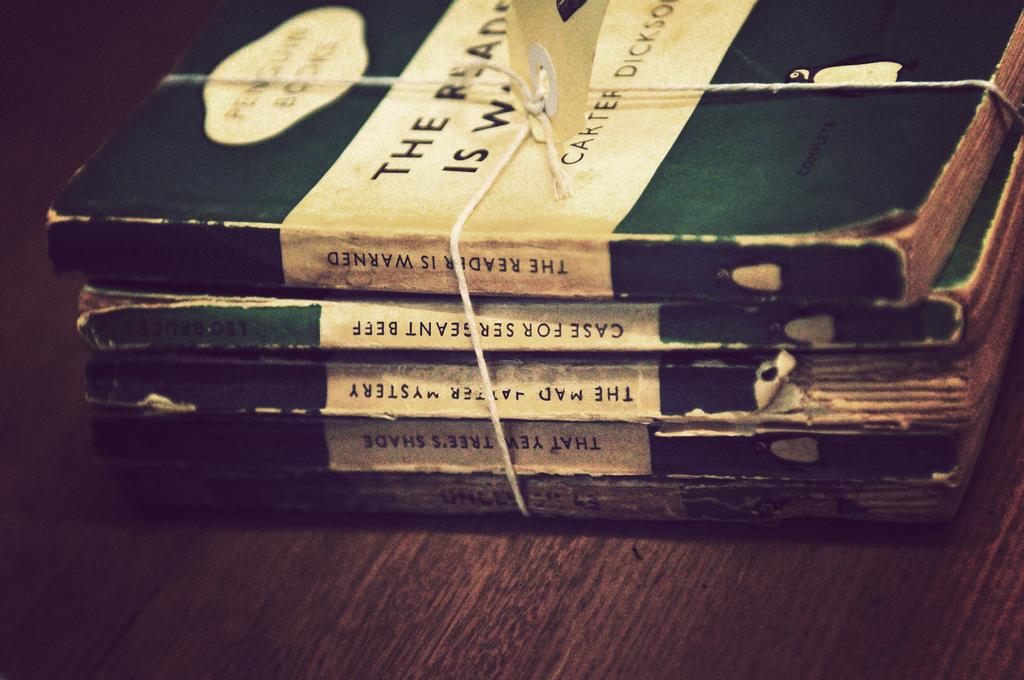<image>
Relay a brief, clear account of the picture shown. Four green books tied together by Carter Dickson. 